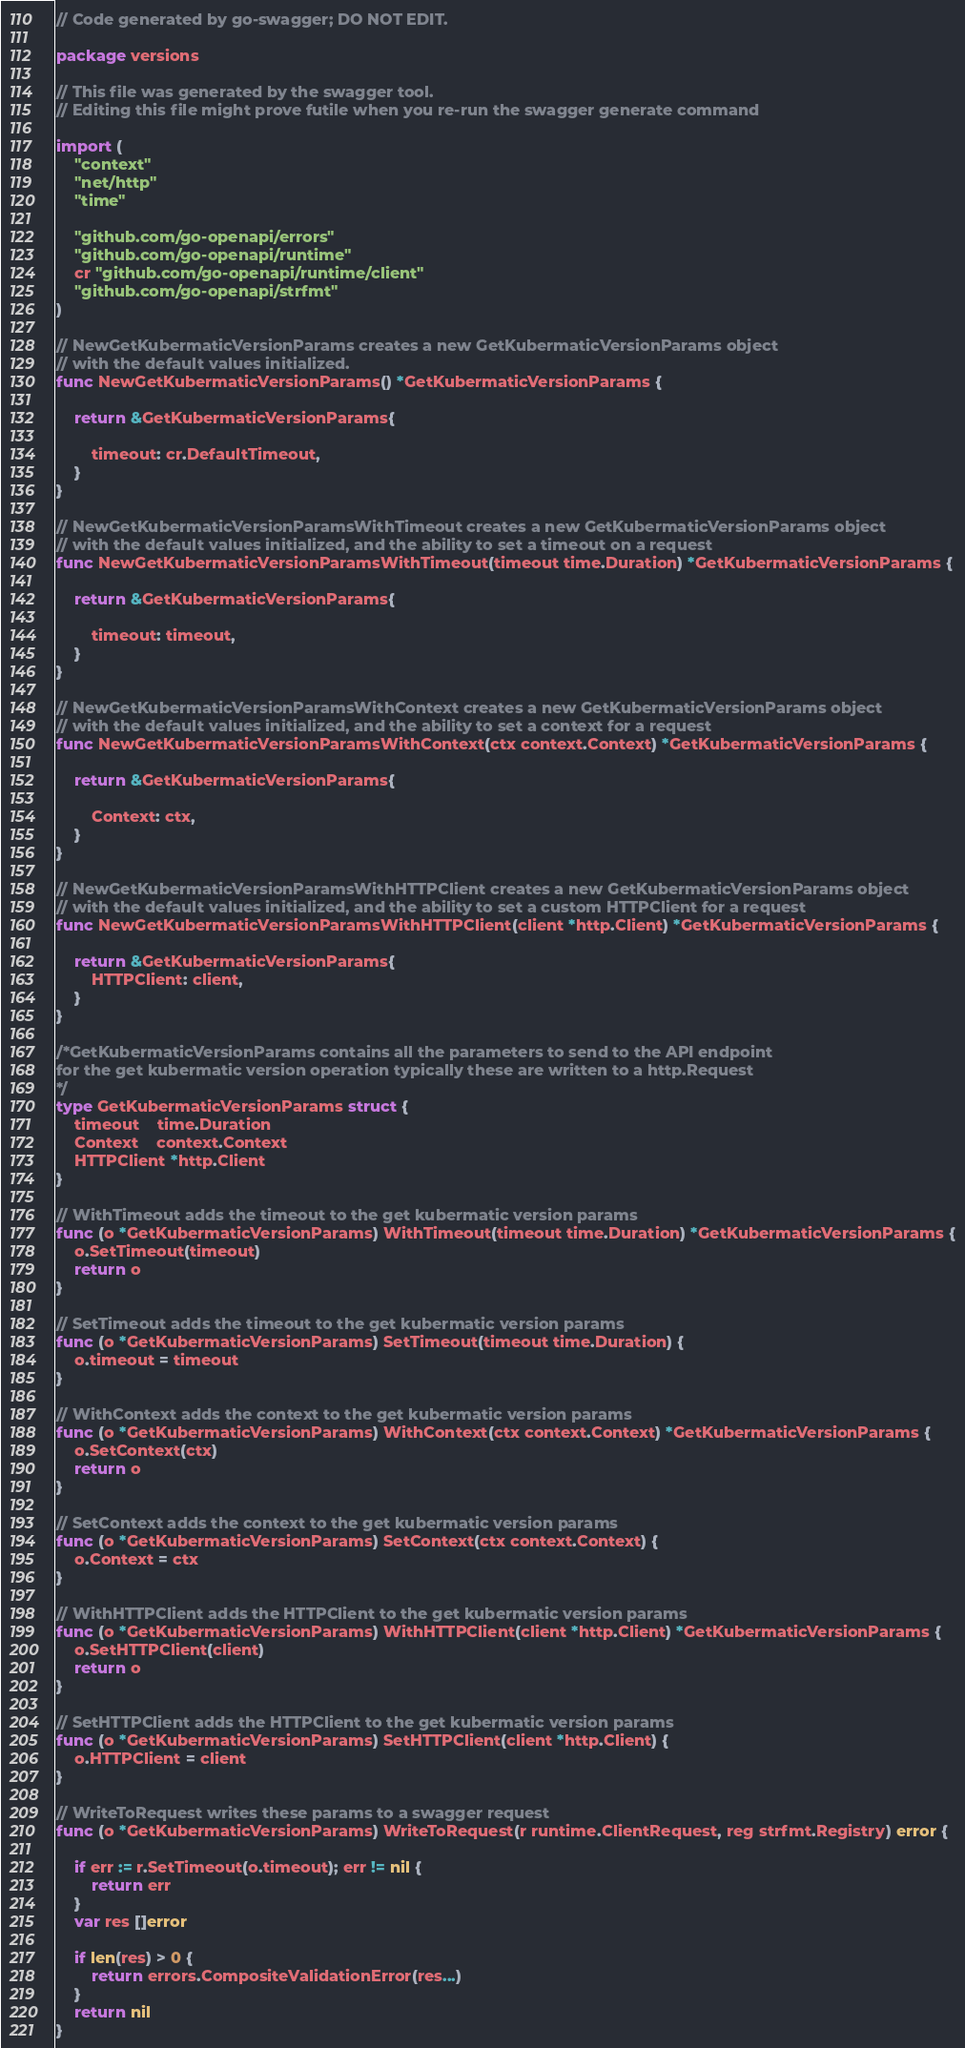<code> <loc_0><loc_0><loc_500><loc_500><_Go_>// Code generated by go-swagger; DO NOT EDIT.

package versions

// This file was generated by the swagger tool.
// Editing this file might prove futile when you re-run the swagger generate command

import (
	"context"
	"net/http"
	"time"

	"github.com/go-openapi/errors"
	"github.com/go-openapi/runtime"
	cr "github.com/go-openapi/runtime/client"
	"github.com/go-openapi/strfmt"
)

// NewGetKubermaticVersionParams creates a new GetKubermaticVersionParams object
// with the default values initialized.
func NewGetKubermaticVersionParams() *GetKubermaticVersionParams {

	return &GetKubermaticVersionParams{

		timeout: cr.DefaultTimeout,
	}
}

// NewGetKubermaticVersionParamsWithTimeout creates a new GetKubermaticVersionParams object
// with the default values initialized, and the ability to set a timeout on a request
func NewGetKubermaticVersionParamsWithTimeout(timeout time.Duration) *GetKubermaticVersionParams {

	return &GetKubermaticVersionParams{

		timeout: timeout,
	}
}

// NewGetKubermaticVersionParamsWithContext creates a new GetKubermaticVersionParams object
// with the default values initialized, and the ability to set a context for a request
func NewGetKubermaticVersionParamsWithContext(ctx context.Context) *GetKubermaticVersionParams {

	return &GetKubermaticVersionParams{

		Context: ctx,
	}
}

// NewGetKubermaticVersionParamsWithHTTPClient creates a new GetKubermaticVersionParams object
// with the default values initialized, and the ability to set a custom HTTPClient for a request
func NewGetKubermaticVersionParamsWithHTTPClient(client *http.Client) *GetKubermaticVersionParams {

	return &GetKubermaticVersionParams{
		HTTPClient: client,
	}
}

/*GetKubermaticVersionParams contains all the parameters to send to the API endpoint
for the get kubermatic version operation typically these are written to a http.Request
*/
type GetKubermaticVersionParams struct {
	timeout    time.Duration
	Context    context.Context
	HTTPClient *http.Client
}

// WithTimeout adds the timeout to the get kubermatic version params
func (o *GetKubermaticVersionParams) WithTimeout(timeout time.Duration) *GetKubermaticVersionParams {
	o.SetTimeout(timeout)
	return o
}

// SetTimeout adds the timeout to the get kubermatic version params
func (o *GetKubermaticVersionParams) SetTimeout(timeout time.Duration) {
	o.timeout = timeout
}

// WithContext adds the context to the get kubermatic version params
func (o *GetKubermaticVersionParams) WithContext(ctx context.Context) *GetKubermaticVersionParams {
	o.SetContext(ctx)
	return o
}

// SetContext adds the context to the get kubermatic version params
func (o *GetKubermaticVersionParams) SetContext(ctx context.Context) {
	o.Context = ctx
}

// WithHTTPClient adds the HTTPClient to the get kubermatic version params
func (o *GetKubermaticVersionParams) WithHTTPClient(client *http.Client) *GetKubermaticVersionParams {
	o.SetHTTPClient(client)
	return o
}

// SetHTTPClient adds the HTTPClient to the get kubermatic version params
func (o *GetKubermaticVersionParams) SetHTTPClient(client *http.Client) {
	o.HTTPClient = client
}

// WriteToRequest writes these params to a swagger request
func (o *GetKubermaticVersionParams) WriteToRequest(r runtime.ClientRequest, reg strfmt.Registry) error {

	if err := r.SetTimeout(o.timeout); err != nil {
		return err
	}
	var res []error

	if len(res) > 0 {
		return errors.CompositeValidationError(res...)
	}
	return nil
}
</code> 